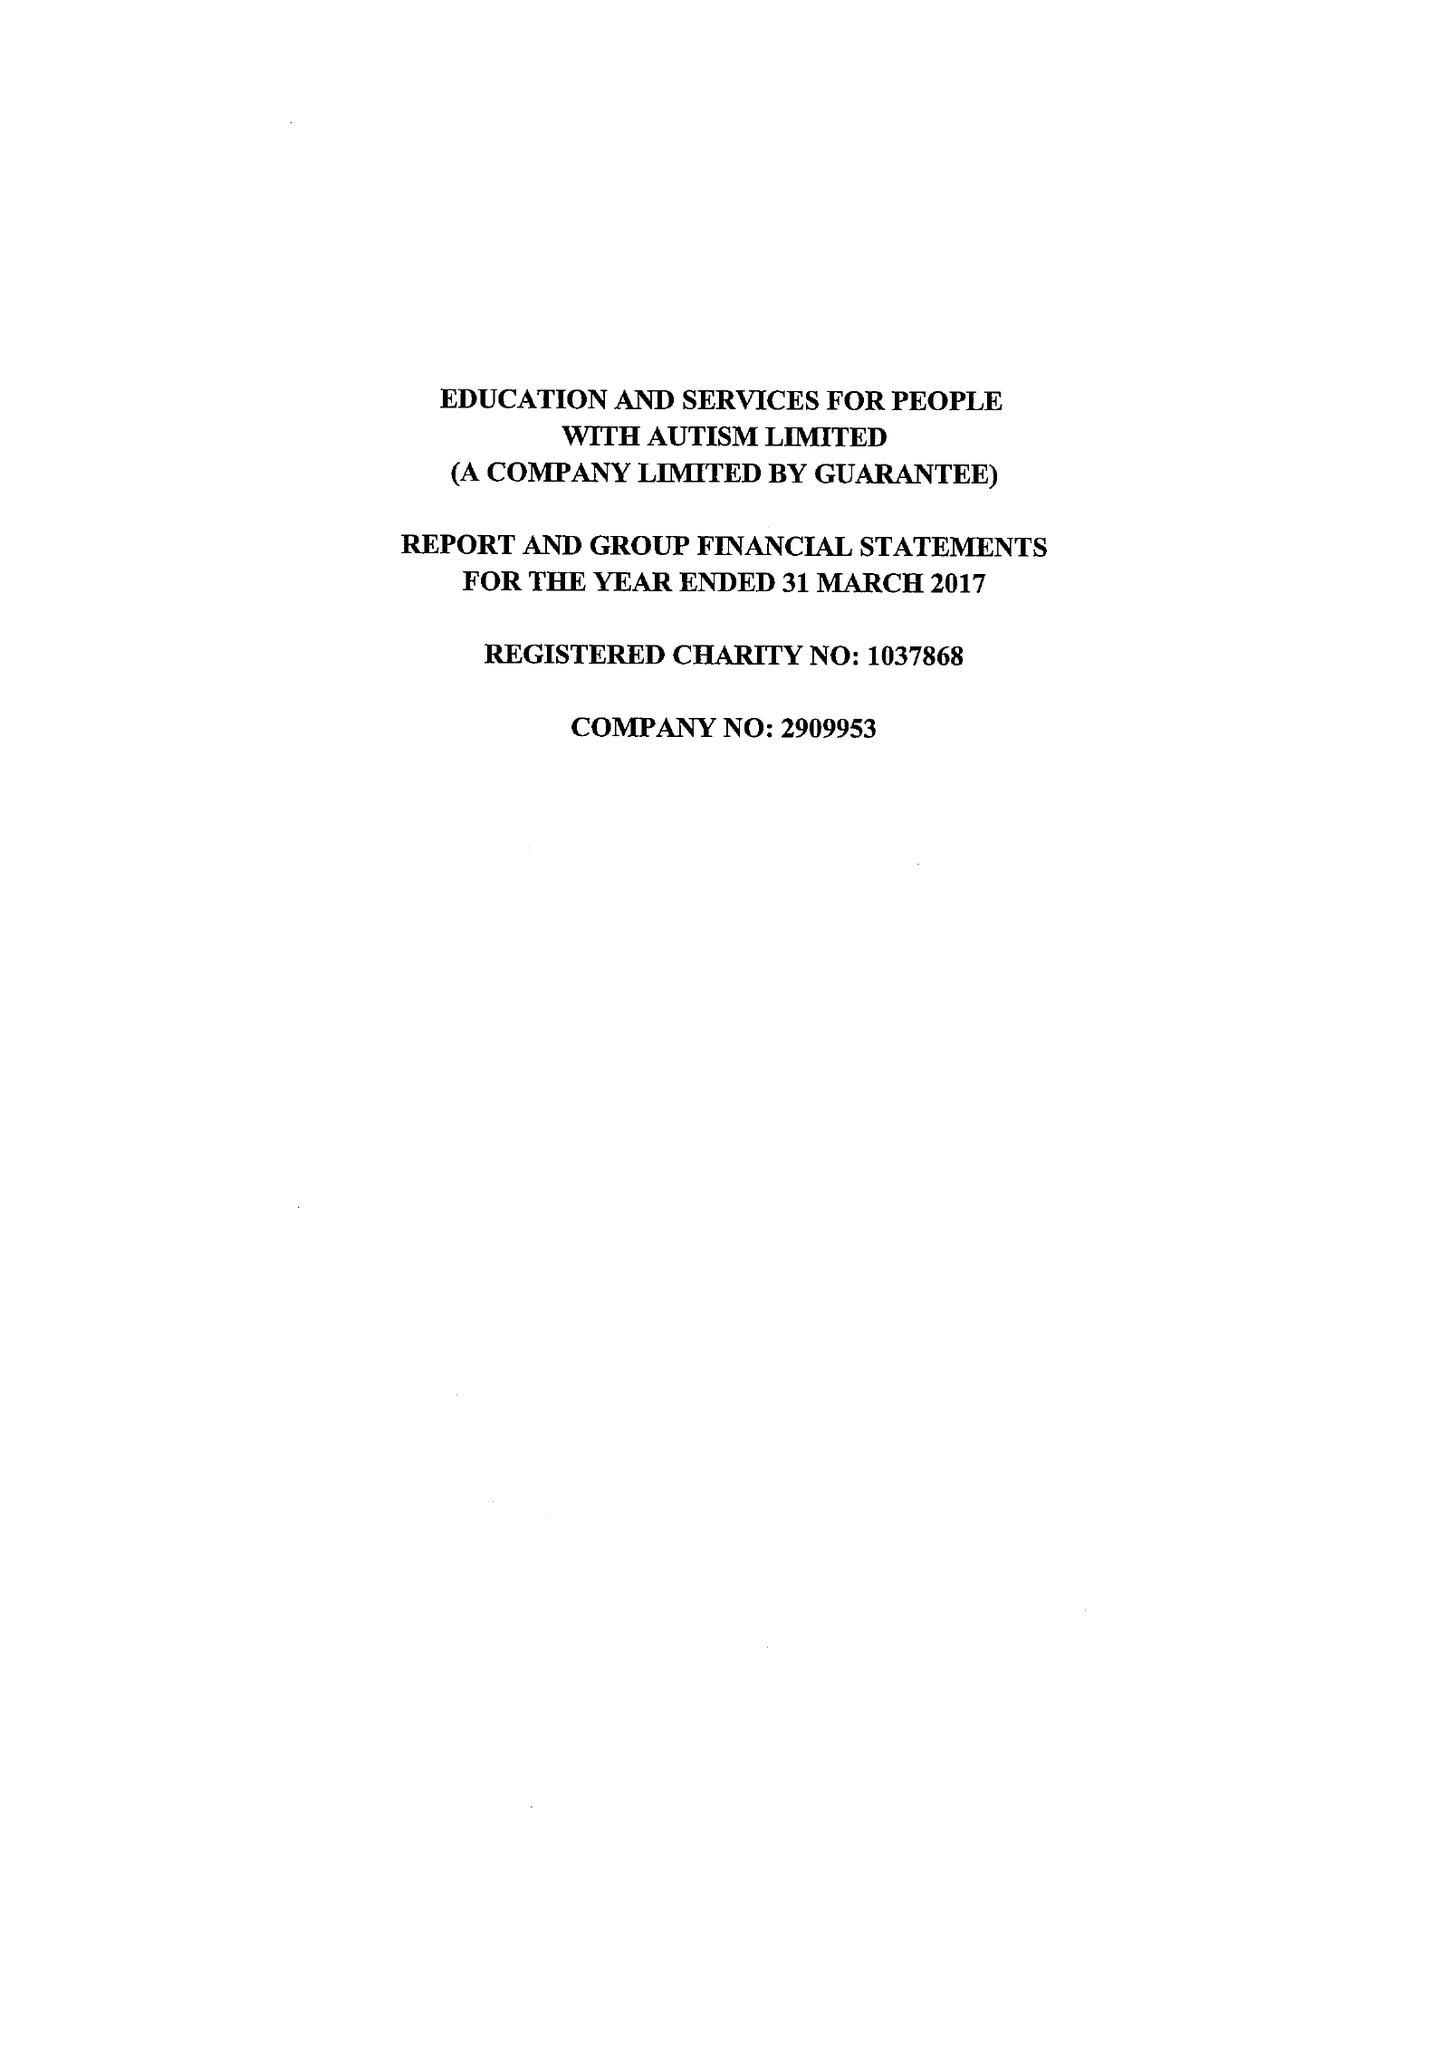What is the value for the spending_annually_in_british_pounds?
Answer the question using a single word or phrase. 12683691.00 